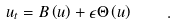Convert formula to latex. <formula><loc_0><loc_0><loc_500><loc_500>u _ { t } = B \left ( u \right ) + \epsilon \Theta \left ( u \right ) \quad .</formula> 